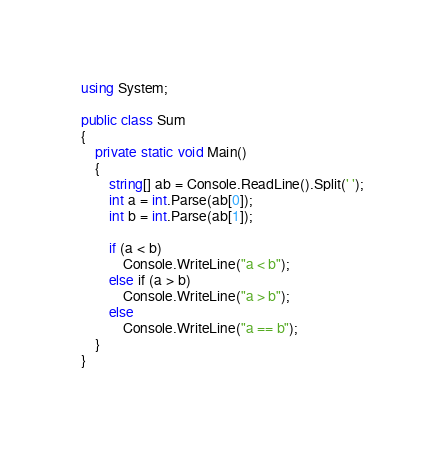Convert code to text. <code><loc_0><loc_0><loc_500><loc_500><_C#_>using System;

public class Sum
{
    private static void Main()
    {
        string[] ab = Console.ReadLine().Split(' ');
        int a = int.Parse(ab[0]);
        int b = int.Parse(ab[1]);

        if (a < b)
            Console.WriteLine("a < b");
        else if (a > b)
            Console.WriteLine("a > b");
        else
            Console.WriteLine("a == b");
    }
}</code> 